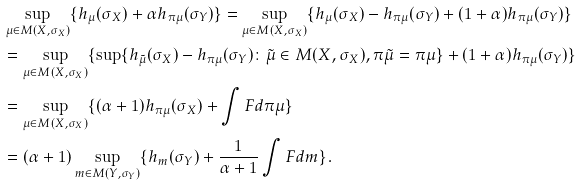Convert formula to latex. <formula><loc_0><loc_0><loc_500><loc_500>& \sup _ { \mu \in M ( X , \sigma _ { X } ) } \{ h _ { \mu } ( \sigma _ { X } ) + \alpha h _ { \pi \mu } ( \sigma _ { Y } ) \} = \sup _ { \mu \in M ( X , \sigma _ { X } ) } \{ h _ { \mu } ( \sigma _ { X } ) - h _ { \pi \mu } ( \sigma _ { Y } ) + ( 1 + \alpha ) h _ { \pi \mu } ( \sigma _ { Y } ) \} \\ & = \sup _ { \mu \in M ( X , \sigma _ { X } ) } \{ \sup \{ h _ { \tilde { \mu } } ( \sigma _ { X } ) - h _ { \pi \mu } ( \sigma _ { Y } ) \colon \tilde { \mu } \in M ( X , \sigma _ { X } ) , \pi { \tilde { \mu } } = \pi \mu \} + ( 1 + \alpha ) h _ { \pi \mu } ( \sigma _ { Y } ) \} \\ & = \sup _ { \mu \in M ( X , \sigma _ { X } ) } \{ ( \alpha + 1 ) h _ { \pi \mu } ( \sigma _ { X } ) + \int F d \pi \mu \} \\ & = ( \alpha + 1 ) \sup _ { m \in M ( Y , \sigma _ { Y } ) } \{ h _ { m } ( \sigma _ { Y } ) + \frac { 1 } { \alpha + 1 } \int F d m \} .</formula> 